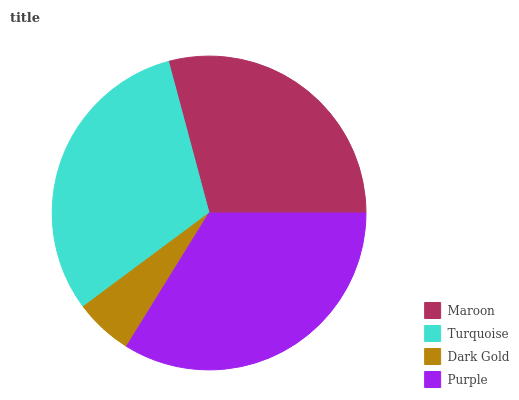Is Dark Gold the minimum?
Answer yes or no. Yes. Is Purple the maximum?
Answer yes or no. Yes. Is Turquoise the minimum?
Answer yes or no. No. Is Turquoise the maximum?
Answer yes or no. No. Is Turquoise greater than Maroon?
Answer yes or no. Yes. Is Maroon less than Turquoise?
Answer yes or no. Yes. Is Maroon greater than Turquoise?
Answer yes or no. No. Is Turquoise less than Maroon?
Answer yes or no. No. Is Turquoise the high median?
Answer yes or no. Yes. Is Maroon the low median?
Answer yes or no. Yes. Is Dark Gold the high median?
Answer yes or no. No. Is Dark Gold the low median?
Answer yes or no. No. 